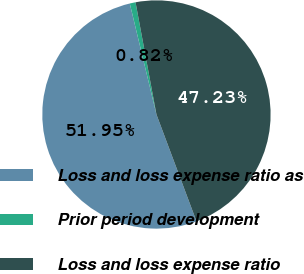Convert chart to OTSL. <chart><loc_0><loc_0><loc_500><loc_500><pie_chart><fcel>Loss and loss expense ratio as<fcel>Prior period development<fcel>Loss and loss expense ratio<nl><fcel>51.95%<fcel>0.82%<fcel>47.23%<nl></chart> 